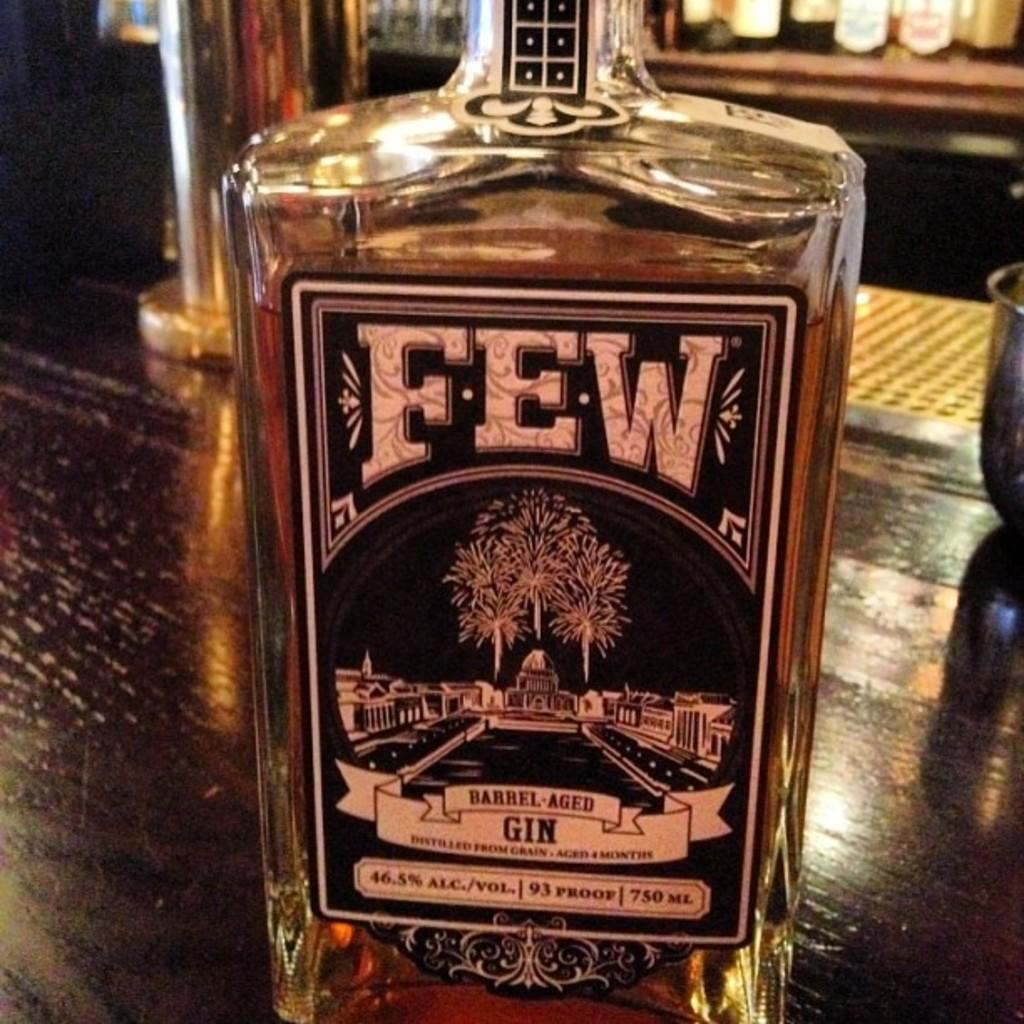<image>
Present a compact description of the photo's key features. A gin bottle from the brand Few which is barrel aged. 